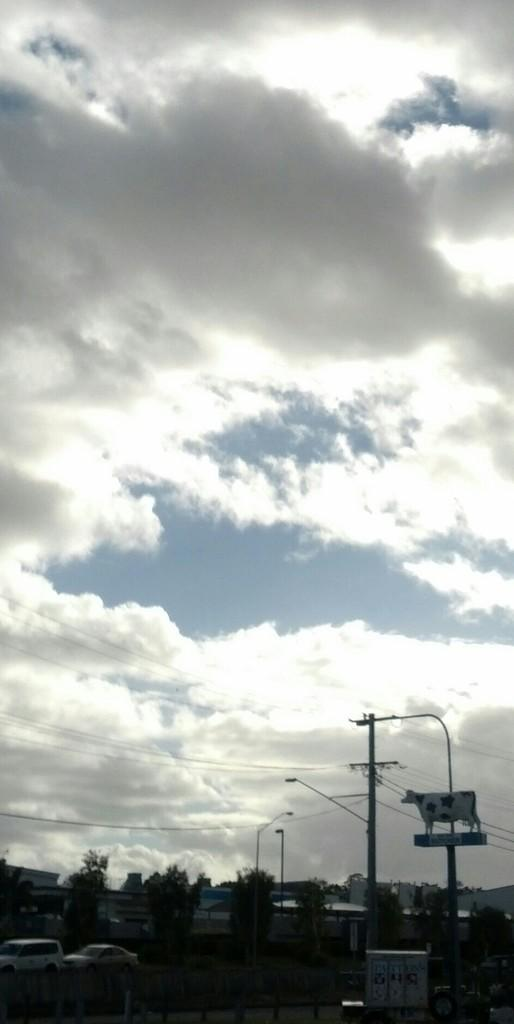What type of vehicles can be seen on the road in the image? There are cars on the road in the image. What can be seen in the distance behind the cars? There are buildings in the background of the image. What is located in front of the buildings? Trees are present in front of the buildings. What is visible above the buildings and trees? The sky is visible in the image. What can be observed in the sky? Clouds are present in the sky. What type of payment is accepted for parking the cars in the image? There is no information about parking or payment in the image, so it cannot be determined. 